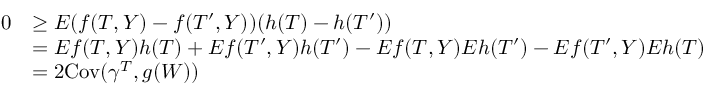<formula> <loc_0><loc_0><loc_500><loc_500>\begin{array} { r l } { 0 } & { \geq E ( f ( T , Y ) - f ( T ^ { \prime } , Y ) ) ( h ( T ) - h ( T ^ { \prime } ) ) } \\ & { = E f ( T , Y ) h ( T ) + E f ( T ^ { \prime } , Y ) h ( T ^ { \prime } ) - E f ( T , Y ) E h ( T ^ { \prime } ) - E f ( T ^ { \prime } , Y ) E h ( T ) } \\ & { = 2 C o v ( \gamma ^ { T } , g ( W ) ) } \end{array}</formula> 